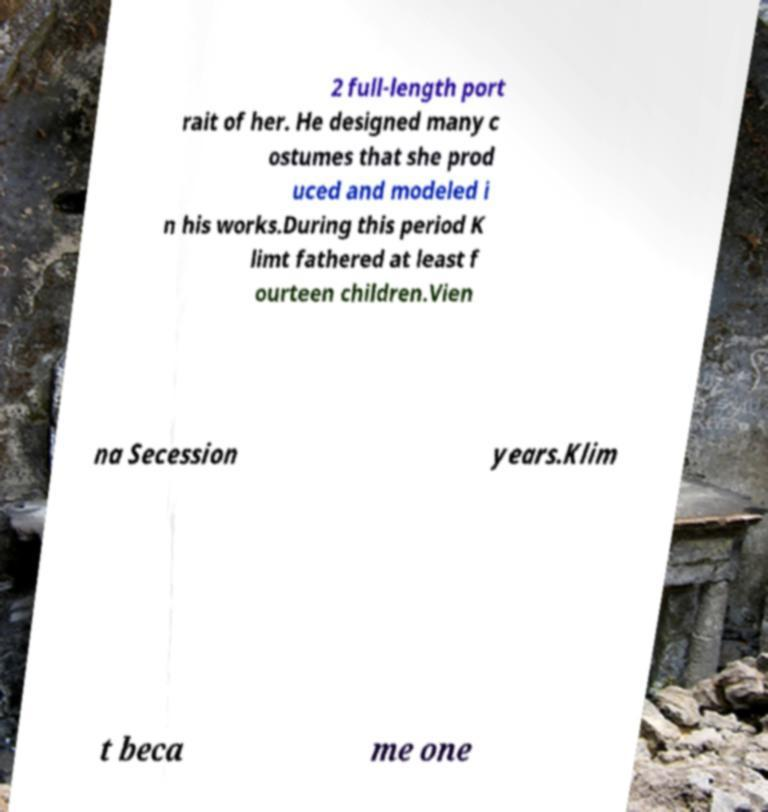Please identify and transcribe the text found in this image. 2 full-length port rait of her. He designed many c ostumes that she prod uced and modeled i n his works.During this period K limt fathered at least f ourteen children.Vien na Secession years.Klim t beca me one 